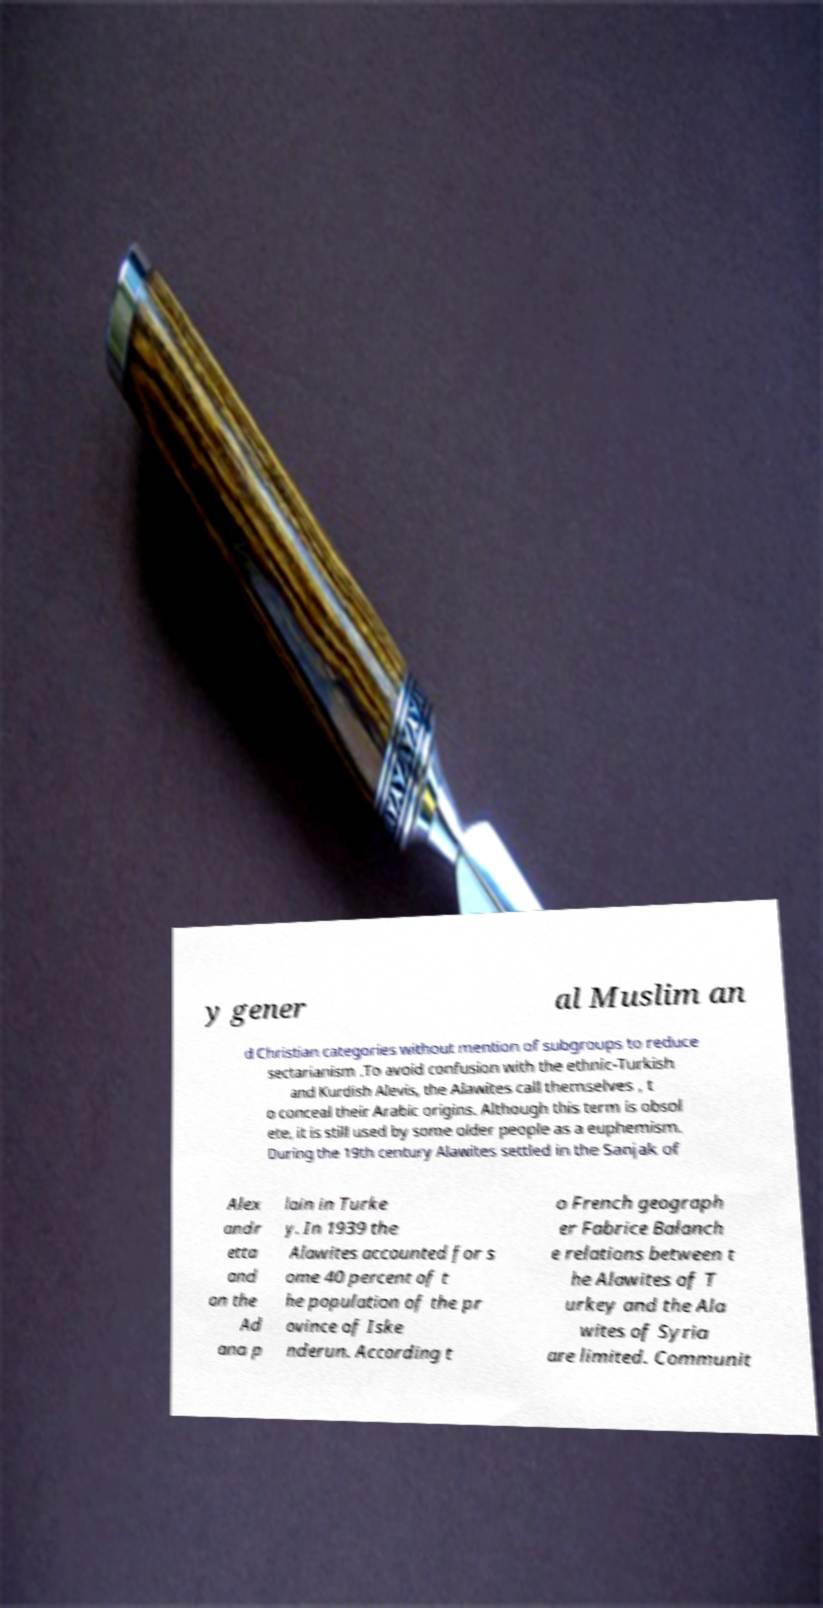Please read and relay the text visible in this image. What does it say? y gener al Muslim an d Christian categories without mention of subgroups to reduce sectarianism .To avoid confusion with the ethnic-Turkish and Kurdish Alevis, the Alawites call themselves , t o conceal their Arabic origins. Although this term is obsol ete, it is still used by some older people as a euphemism. During the 19th century Alawites settled in the Sanjak of Alex andr etta and on the Ad ana p lain in Turke y. In 1939 the Alawites accounted for s ome 40 percent of t he population of the pr ovince of Iske nderun. According t o French geograph er Fabrice Balanch e relations between t he Alawites of T urkey and the Ala wites of Syria are limited. Communit 